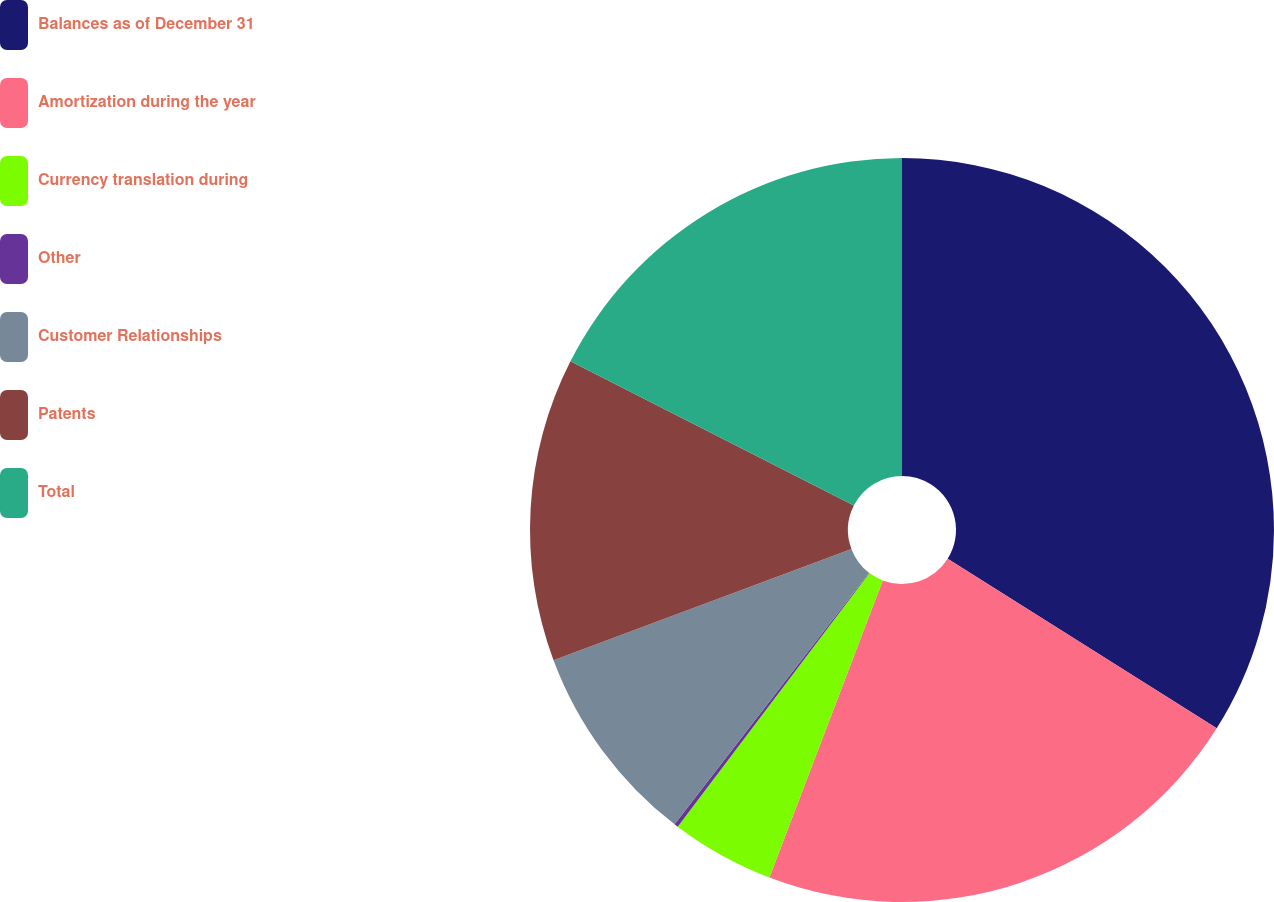Convert chart to OTSL. <chart><loc_0><loc_0><loc_500><loc_500><pie_chart><fcel>Balances as of December 31<fcel>Amortization during the year<fcel>Currency translation during<fcel>Other<fcel>Customer Relationships<fcel>Patents<fcel>Total<nl><fcel>33.95%<fcel>21.85%<fcel>4.5%<fcel>0.17%<fcel>8.84%<fcel>13.18%<fcel>17.51%<nl></chart> 